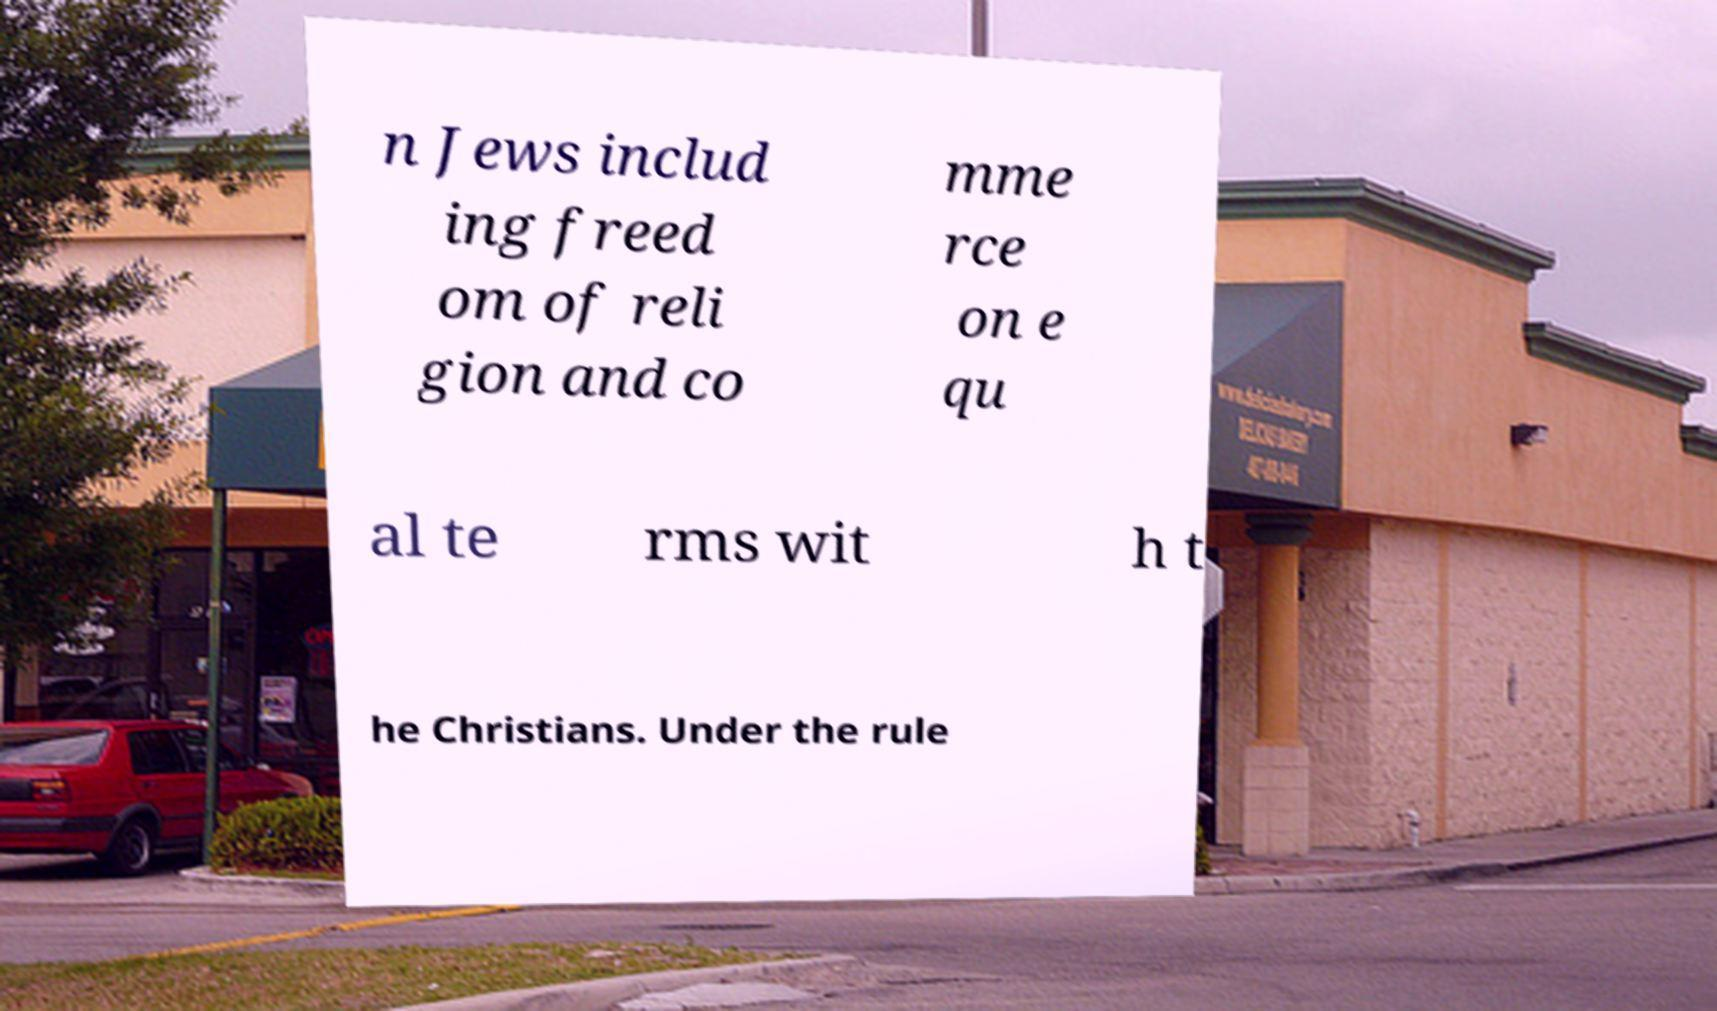I need the written content from this picture converted into text. Can you do that? n Jews includ ing freed om of reli gion and co mme rce on e qu al te rms wit h t he Christians. Under the rule 